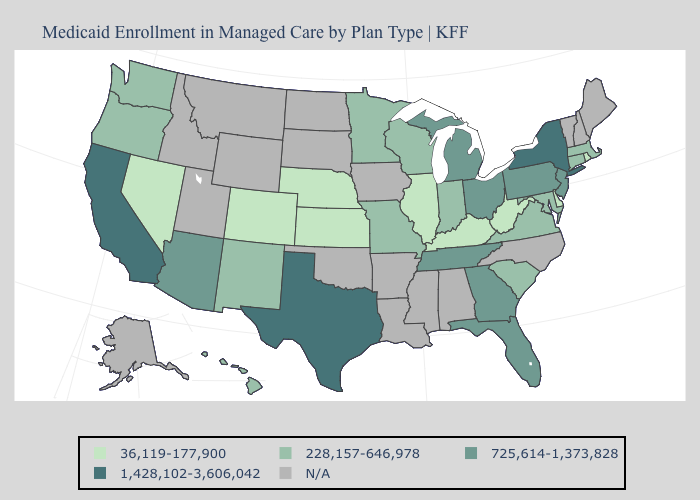Name the states that have a value in the range 36,119-177,900?
Short answer required. Colorado, Delaware, Illinois, Kansas, Kentucky, Nebraska, Nevada, Rhode Island, West Virginia. What is the value of Michigan?
Keep it brief. 725,614-1,373,828. What is the value of Florida?
Short answer required. 725,614-1,373,828. What is the value of Mississippi?
Quick response, please. N/A. Does the map have missing data?
Keep it brief. Yes. What is the lowest value in the USA?
Be succinct. 36,119-177,900. Does the first symbol in the legend represent the smallest category?
Short answer required. Yes. What is the value of Vermont?
Quick response, please. N/A. What is the value of Washington?
Short answer required. 228,157-646,978. Name the states that have a value in the range 725,614-1,373,828?
Be succinct. Arizona, Florida, Georgia, Michigan, New Jersey, Ohio, Pennsylvania, Tennessee. What is the lowest value in the USA?
Answer briefly. 36,119-177,900. Does Texas have the lowest value in the South?
Be succinct. No. Which states have the lowest value in the USA?
Keep it brief. Colorado, Delaware, Illinois, Kansas, Kentucky, Nebraska, Nevada, Rhode Island, West Virginia. 